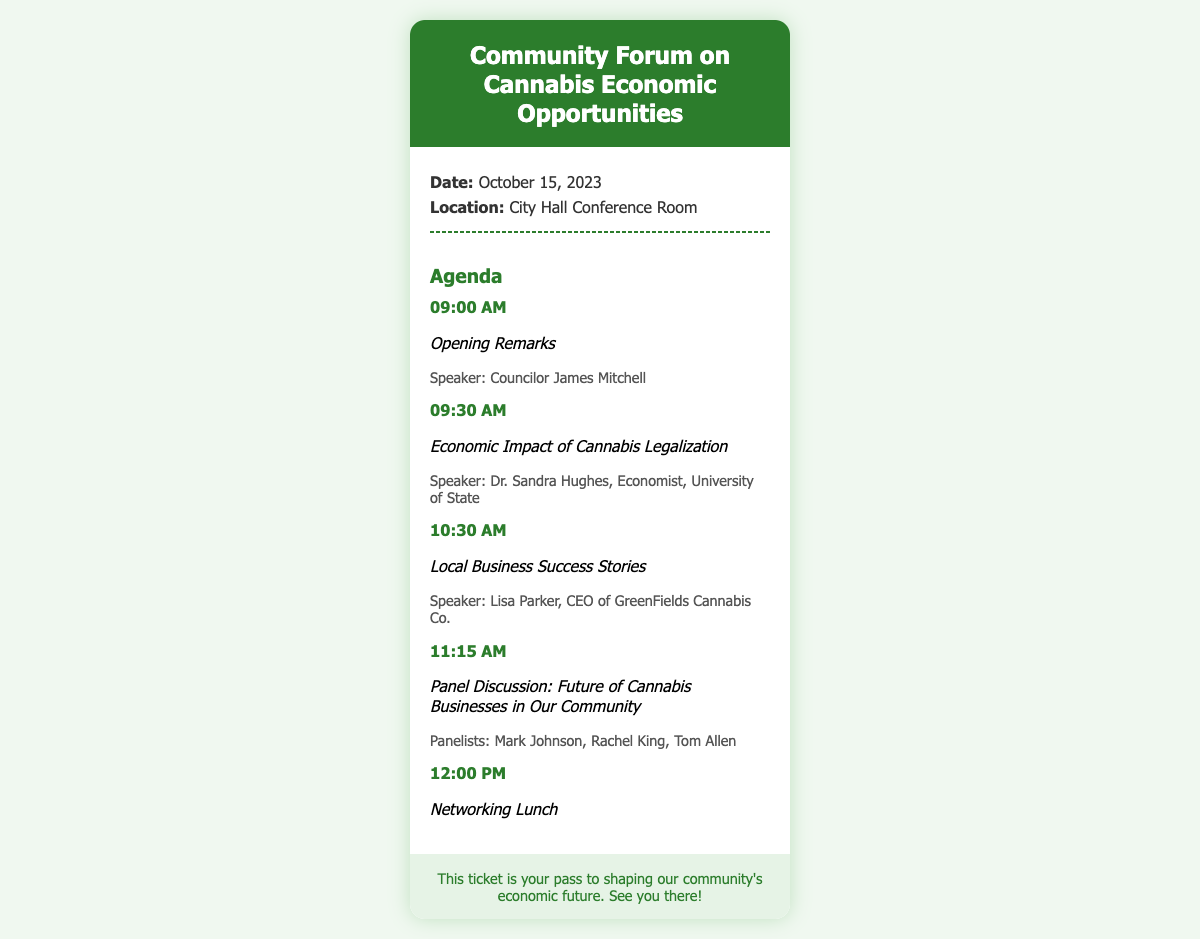What is the date of the event? The date of the event is clearly stated in the document.
Answer: October 15, 2023 Where is the forum being held? The location of the forum is mentioned in the ticket details.
Answer: City Hall Conference Room Who is the speaker for the economic impact session? The speaker for the economic impact session is listed in the agenda section of the document.
Answer: Dr. Sandra Hughes What time does the networking lunch start? The time for the networking lunch is provided in the agenda.
Answer: 12:00 PM What is the title of the panel discussion? The title of the panel discussion is given in the agenda section of the document.
Answer: Future of Cannabis Businesses in Our Community How many speakers are listed for the panel discussion? The number of speakers for the panel discussion can be determined from their names listed in the agenda.
Answer: Three What is a key goal of the event as indicated in the footer? The key goal of the event is summarized in the closing statement in the document.
Answer: Shaping our community's economic future 